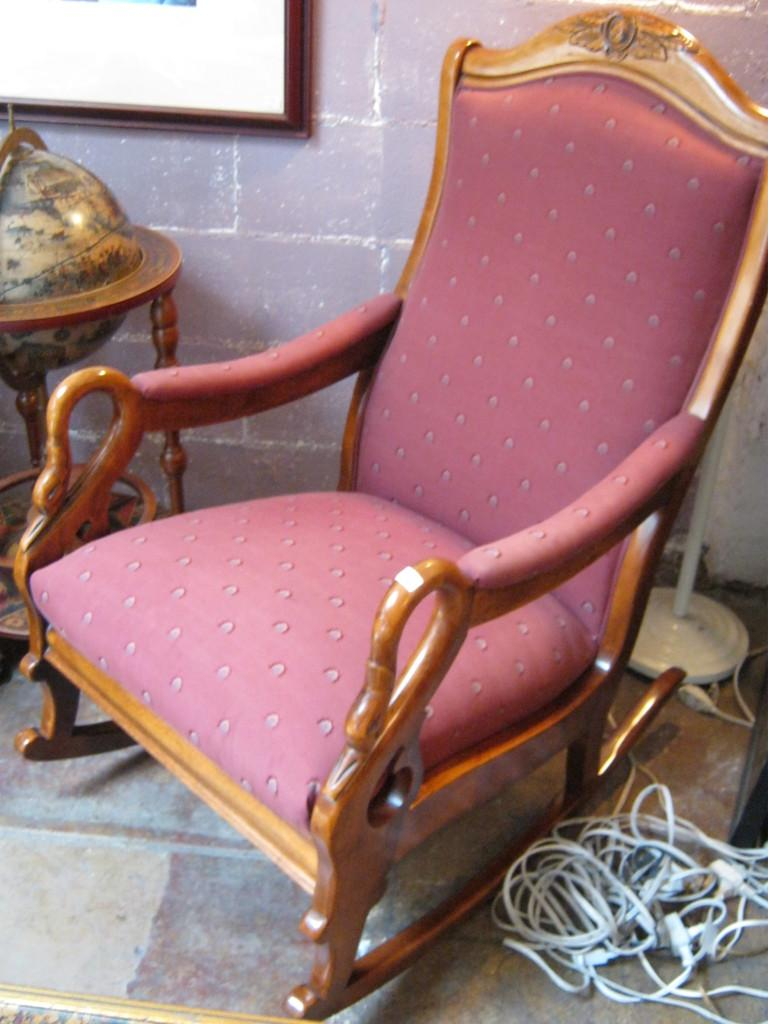What color is the chair in the image? The chair in the image is pink. What else can be seen in the image besides the chair? There are wires visible in the image. What color is the wall in the image? The wall in the image is purple. What is the color of the brown object in the image? The brown object in the image is brown. Are there any cacti visible in the image? No, there are no cacti present in the image. What type of waste can be seen in the image? There is no waste visible in the image. 